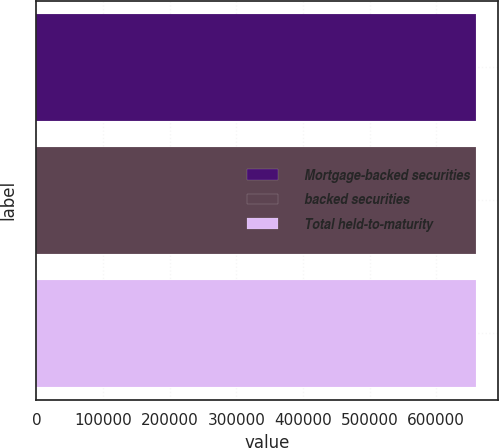<chart> <loc_0><loc_0><loc_500><loc_500><bar_chart><fcel>Mortgage-backed securities<fcel>backed securities<fcel>Total held-to-maturity<nl><fcel>660186<fcel>660186<fcel>660186<nl></chart> 